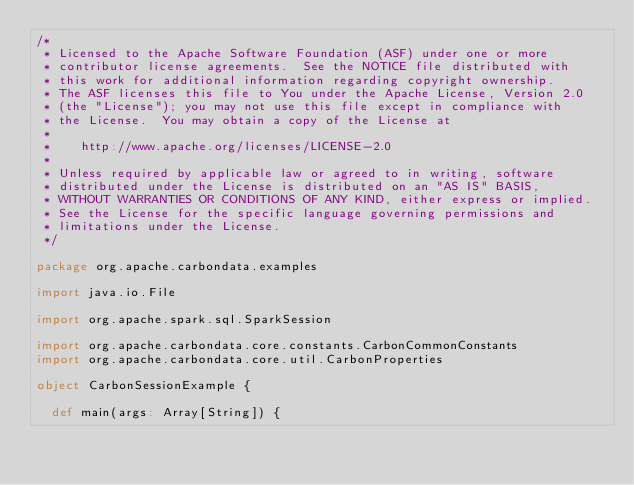Convert code to text. <code><loc_0><loc_0><loc_500><loc_500><_Scala_>/*
 * Licensed to the Apache Software Foundation (ASF) under one or more
 * contributor license agreements.  See the NOTICE file distributed with
 * this work for additional information regarding copyright ownership.
 * The ASF licenses this file to You under the Apache License, Version 2.0
 * (the "License"); you may not use this file except in compliance with
 * the License.  You may obtain a copy of the License at
 *
 *    http://www.apache.org/licenses/LICENSE-2.0
 *
 * Unless required by applicable law or agreed to in writing, software
 * distributed under the License is distributed on an "AS IS" BASIS,
 * WITHOUT WARRANTIES OR CONDITIONS OF ANY KIND, either express or implied.
 * See the License for the specific language governing permissions and
 * limitations under the License.
 */

package org.apache.carbondata.examples

import java.io.File

import org.apache.spark.sql.SparkSession

import org.apache.carbondata.core.constants.CarbonCommonConstants
import org.apache.carbondata.core.util.CarbonProperties

object CarbonSessionExample {

  def main(args: Array[String]) {</code> 